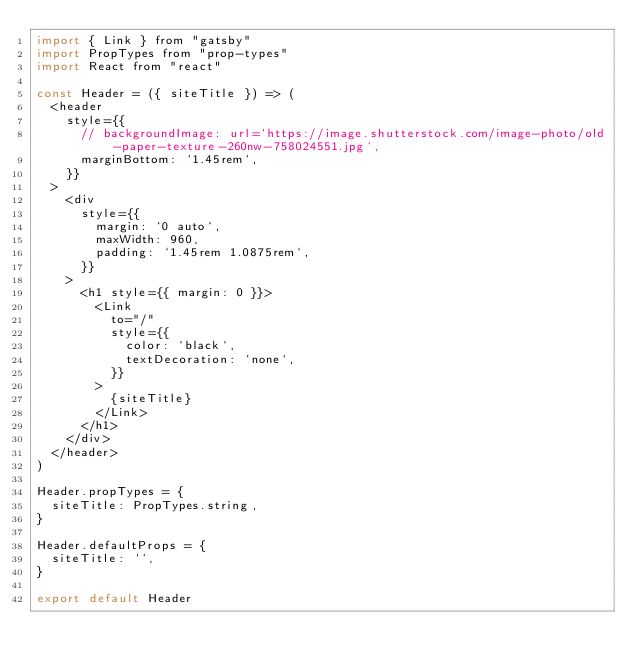<code> <loc_0><loc_0><loc_500><loc_500><_JavaScript_>import { Link } from "gatsby"
import PropTypes from "prop-types"
import React from "react"

const Header = ({ siteTitle }) => (
  <header
    style={{
      // backgroundImage: url=`https://image.shutterstock.com/image-photo/old-paper-texture-260nw-758024551.jpg`,
      marginBottom: `1.45rem`,
    }}
  >
    <div
      style={{
        margin: `0 auto`,
        maxWidth: 960,
        padding: `1.45rem 1.0875rem`,
      }}
    >
      <h1 style={{ margin: 0 }}>
        <Link
          to="/"
          style={{
            color: `black`,
            textDecoration: `none`,
          }}
        >
          {siteTitle}
        </Link>
      </h1>
    </div>
  </header>
)

Header.propTypes = {
  siteTitle: PropTypes.string,
}

Header.defaultProps = {
  siteTitle: ``,
}

export default Header
</code> 